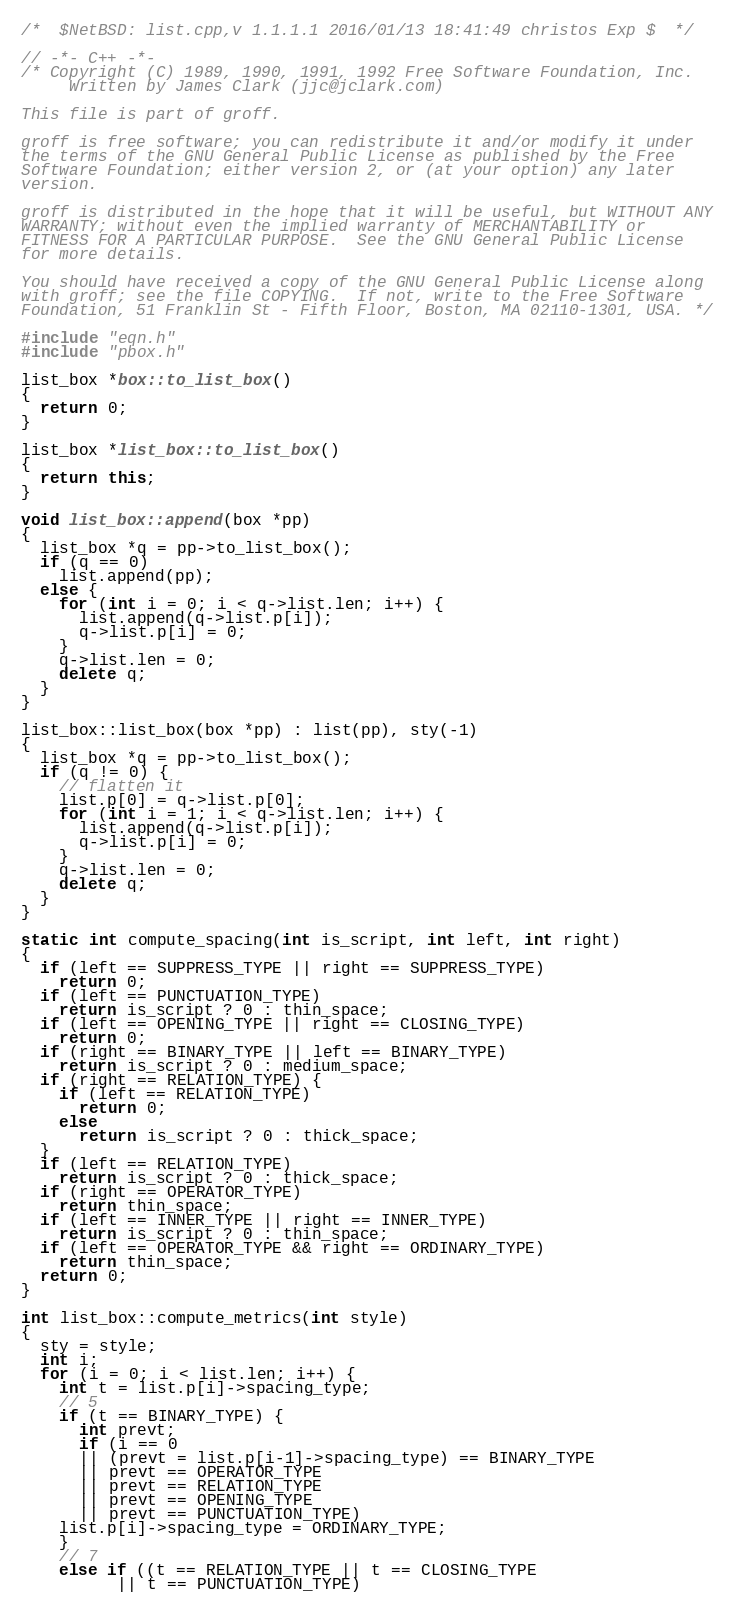<code> <loc_0><loc_0><loc_500><loc_500><_C++_>/*	$NetBSD: list.cpp,v 1.1.1.1 2016/01/13 18:41:49 christos Exp $	*/

// -*- C++ -*-
/* Copyright (C) 1989, 1990, 1991, 1992 Free Software Foundation, Inc.
     Written by James Clark (jjc@jclark.com)

This file is part of groff.

groff is free software; you can redistribute it and/or modify it under
the terms of the GNU General Public License as published by the Free
Software Foundation; either version 2, or (at your option) any later
version.

groff is distributed in the hope that it will be useful, but WITHOUT ANY
WARRANTY; without even the implied warranty of MERCHANTABILITY or
FITNESS FOR A PARTICULAR PURPOSE.  See the GNU General Public License
for more details.

You should have received a copy of the GNU General Public License along
with groff; see the file COPYING.  If not, write to the Free Software
Foundation, 51 Franklin St - Fifth Floor, Boston, MA 02110-1301, USA. */

#include "eqn.h"
#include "pbox.h"

list_box *box::to_list_box()
{
  return 0;
}

list_box *list_box::to_list_box()
{
  return this;
}

void list_box::append(box *pp)
{
  list_box *q = pp->to_list_box();
  if (q == 0)
    list.append(pp);
  else {
    for (int i = 0; i < q->list.len; i++) {
      list.append(q->list.p[i]);
      q->list.p[i] = 0;
    }
    q->list.len = 0;
    delete q;
  }
}

list_box::list_box(box *pp) : list(pp), sty(-1)
{
  list_box *q = pp->to_list_box();
  if (q != 0) {
    // flatten it
    list.p[0] = q->list.p[0];
    for (int i = 1; i < q->list.len; i++) {
      list.append(q->list.p[i]);
      q->list.p[i] = 0;
    }
    q->list.len = 0;
    delete q;
  }
}

static int compute_spacing(int is_script, int left, int right)
{
  if (left == SUPPRESS_TYPE || right == SUPPRESS_TYPE)
    return 0;
  if (left == PUNCTUATION_TYPE)
    return is_script ? 0 : thin_space;
  if (left == OPENING_TYPE || right == CLOSING_TYPE)
    return 0;
  if (right == BINARY_TYPE || left == BINARY_TYPE)
    return is_script ? 0 : medium_space;
  if (right == RELATION_TYPE) {
    if (left == RELATION_TYPE)
      return 0;
    else
      return is_script ? 0 : thick_space;
  }
  if (left == RELATION_TYPE)
    return is_script ? 0 : thick_space;
  if (right == OPERATOR_TYPE)
    return thin_space;
  if (left == INNER_TYPE || right == INNER_TYPE)
    return is_script ? 0 : thin_space;
  if (left == OPERATOR_TYPE && right == ORDINARY_TYPE)
    return thin_space;
  return 0;
}

int list_box::compute_metrics(int style)
{
  sty = style;
  int i;
  for (i = 0; i < list.len; i++) {
    int t = list.p[i]->spacing_type; 
    // 5
    if (t == BINARY_TYPE) {
      int prevt;
      if (i == 0
	  || (prevt = list.p[i-1]->spacing_type) == BINARY_TYPE
	  || prevt == OPERATOR_TYPE
	  || prevt == RELATION_TYPE
	  || prevt == OPENING_TYPE
	  || prevt == PUNCTUATION_TYPE)
	list.p[i]->spacing_type = ORDINARY_TYPE;
    }
    // 7
    else if ((t == RELATION_TYPE || t == CLOSING_TYPE 
	      || t == PUNCTUATION_TYPE)</code> 